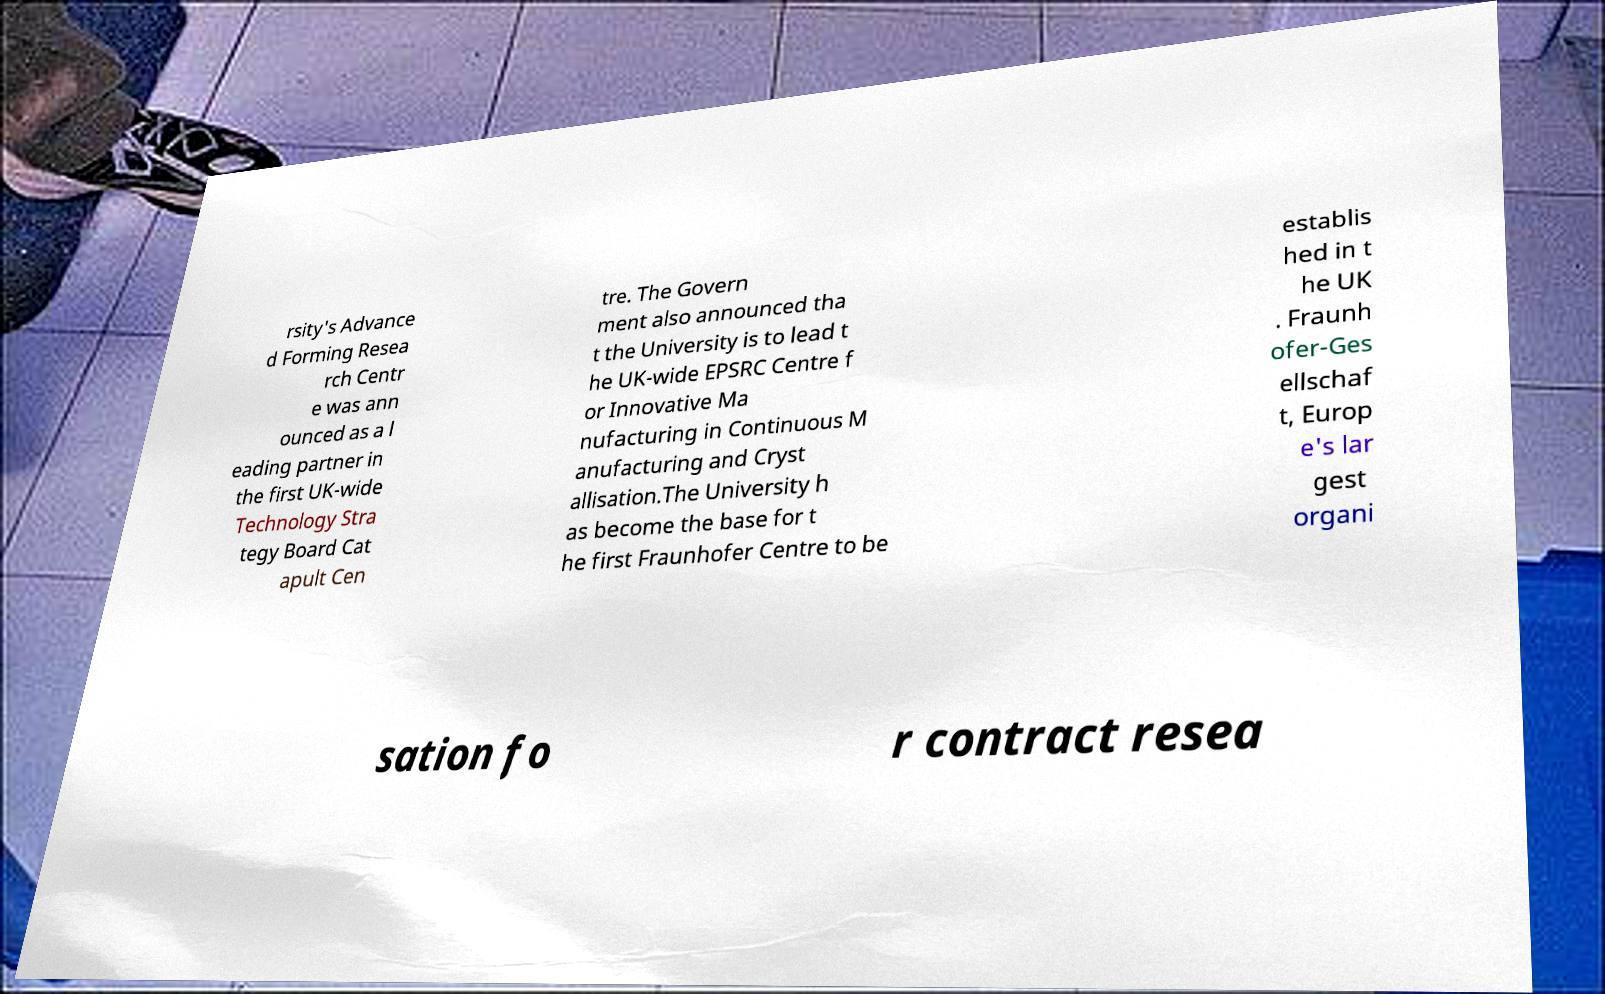I need the written content from this picture converted into text. Can you do that? rsity's Advance d Forming Resea rch Centr e was ann ounced as a l eading partner in the first UK-wide Technology Stra tegy Board Cat apult Cen tre. The Govern ment also announced tha t the University is to lead t he UK-wide EPSRC Centre f or Innovative Ma nufacturing in Continuous M anufacturing and Cryst allisation.The University h as become the base for t he first Fraunhofer Centre to be establis hed in t he UK . Fraunh ofer-Ges ellschaf t, Europ e's lar gest organi sation fo r contract resea 